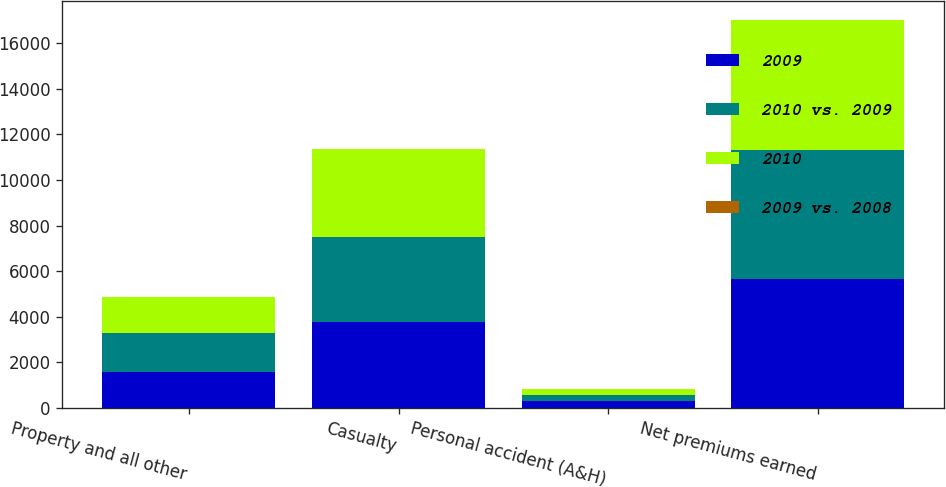<chart> <loc_0><loc_0><loc_500><loc_500><stacked_bar_chart><ecel><fcel>Property and all other<fcel>Casualty<fcel>Personal accident (A&H)<fcel>Net premiums earned<nl><fcel>2009<fcel>1578<fcel>3777<fcel>296<fcel>5651<nl><fcel>2010 vs. 2009<fcel>1690<fcel>3734<fcel>260<fcel>5684<nl><fcel>2010<fcel>1576<fcel>3857<fcel>246<fcel>5679<nl><fcel>2009 vs. 2008<fcel>7<fcel>1<fcel>14<fcel>1<nl></chart> 